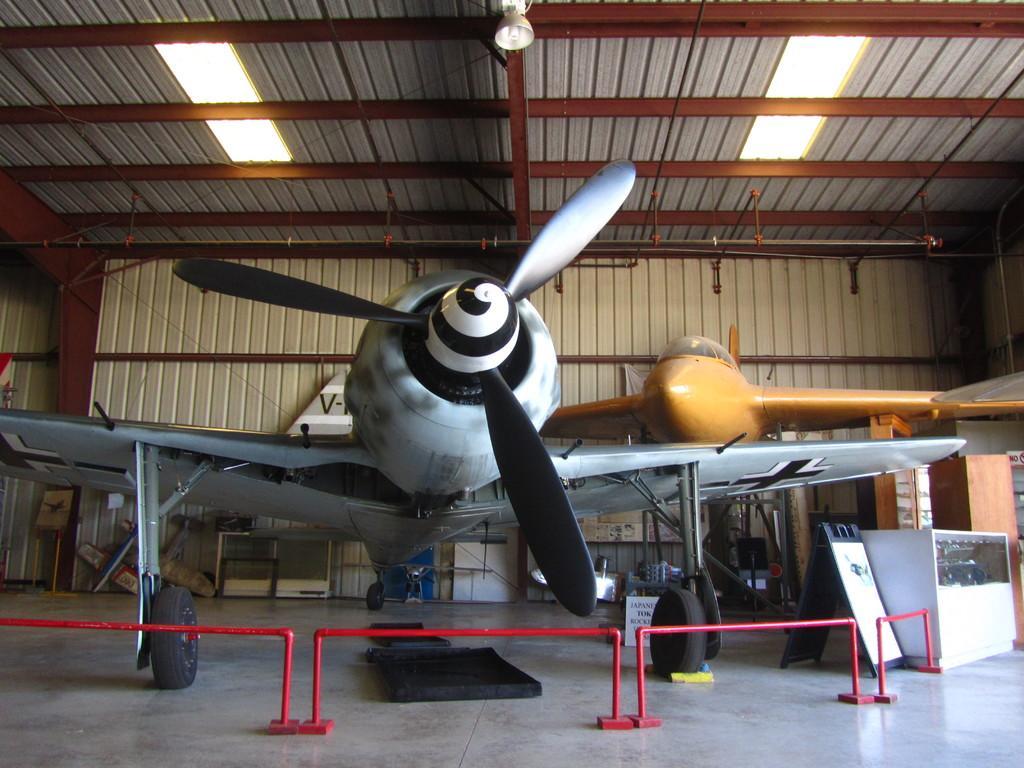Please provide a concise description of this image. In this image there is a shed, in that shed there are two airplanes, in front there is a railing. 